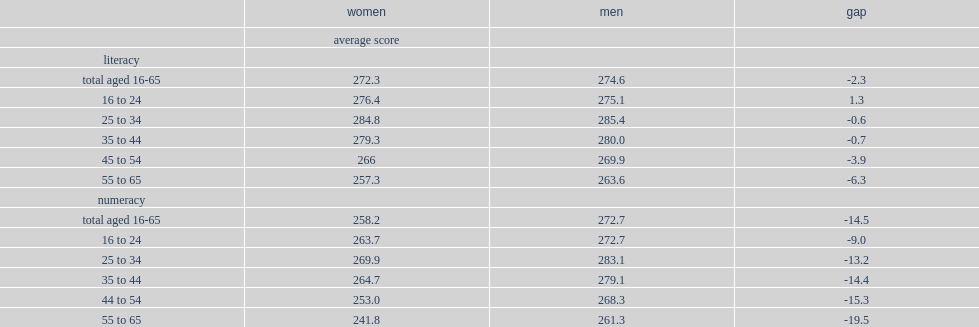Which age group had the lowest literacy proficiency scores for women and men respectively? 55 to 65. What was the gap (men-women) in literacy proficiency scores among those aged 55 to 65? 6.3. Who had a lower numeracy scores in every age cohort,women or men? Women. What was the gap in numeracy scores between women and men aged 16 to 24 and for those aged 55 to 65 respectively? -9.0 -19.5. 